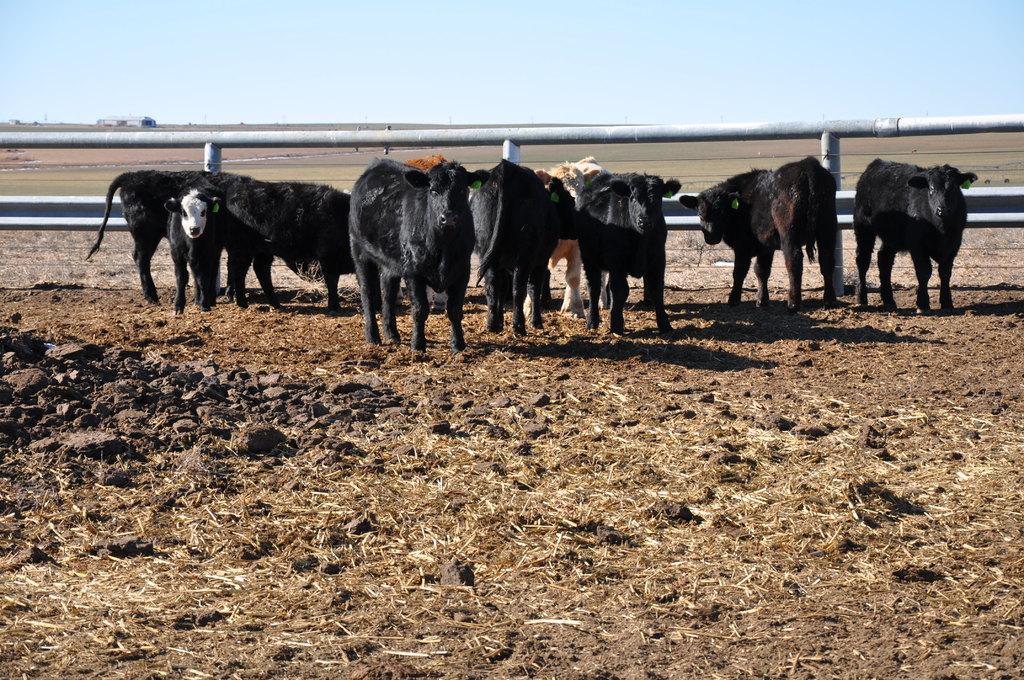Please provide a concise description of this image. In this picture I can see the soil in front and I see few animals and the fencing in the middle of this picture. In the background I see the sky. 